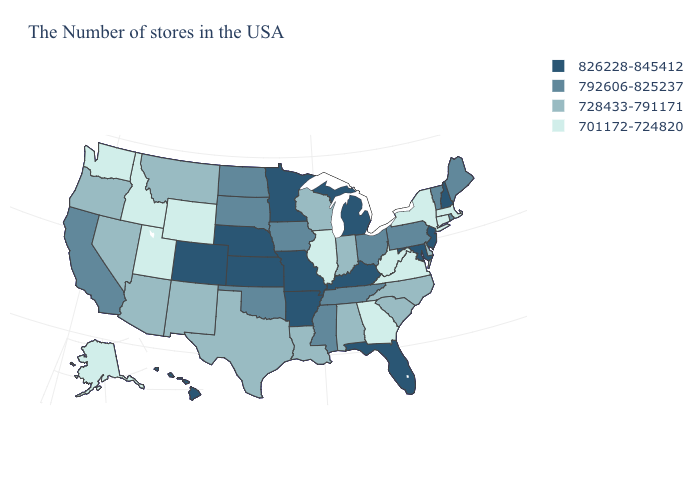Does New Hampshire have the highest value in the Northeast?
Quick response, please. Yes. Name the states that have a value in the range 826228-845412?
Short answer required. New Hampshire, New Jersey, Maryland, Florida, Michigan, Kentucky, Missouri, Arkansas, Minnesota, Kansas, Nebraska, Colorado, Hawaii. What is the lowest value in the USA?
Short answer required. 701172-724820. Name the states that have a value in the range 728433-791171?
Short answer required. Delaware, North Carolina, South Carolina, Indiana, Alabama, Wisconsin, Louisiana, Texas, New Mexico, Montana, Arizona, Nevada, Oregon. What is the lowest value in states that border Florida?
Concise answer only. 701172-724820. Name the states that have a value in the range 826228-845412?
Keep it brief. New Hampshire, New Jersey, Maryland, Florida, Michigan, Kentucky, Missouri, Arkansas, Minnesota, Kansas, Nebraska, Colorado, Hawaii. What is the lowest value in states that border Illinois?
Keep it brief. 728433-791171. Which states hav the highest value in the Northeast?
Give a very brief answer. New Hampshire, New Jersey. Which states hav the highest value in the MidWest?
Concise answer only. Michigan, Missouri, Minnesota, Kansas, Nebraska. Does Minnesota have the same value as Florida?
Answer briefly. Yes. Does Montana have the highest value in the West?
Answer briefly. No. How many symbols are there in the legend?
Write a very short answer. 4. Does the first symbol in the legend represent the smallest category?
Answer briefly. No. Name the states that have a value in the range 826228-845412?
Answer briefly. New Hampshire, New Jersey, Maryland, Florida, Michigan, Kentucky, Missouri, Arkansas, Minnesota, Kansas, Nebraska, Colorado, Hawaii. 